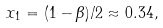Convert formula to latex. <formula><loc_0><loc_0><loc_500><loc_500>x _ { 1 } = ( 1 - \beta ) / 2 \approx 0 . 3 4 ,</formula> 